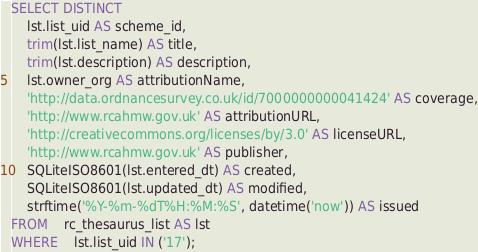<code> <loc_0><loc_0><loc_500><loc_500><_SQL_>SELECT DISTINCT
	lst.list_uid AS scheme_id,
	trim(lst.list_name) AS title,
	trim(lst.description) AS description,
	lst.owner_org AS attributionName,
	'http://data.ordnancesurvey.co.uk/id/7000000000041424' AS coverage,
	'http://www.rcahmw.gov.uk' AS attributionURL,
	'http://creativecommons.org/licenses/by/3.0' AS licenseURL,
	'http://www.rcahmw.gov.uk' AS publisher,
	SQLiteISO8601(lst.entered_dt) AS created,
	SQLiteISO8601(lst.updated_dt) AS modified,
	strftime('%Y-%m-%dT%H:%M:%S', datetime('now')) AS issued
FROM	rc_thesaurus_list AS lst
WHERE	lst.list_uid IN ('17');</code> 